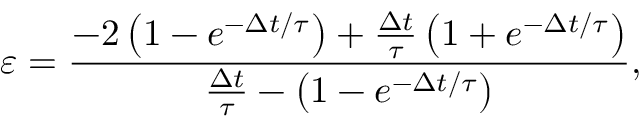Convert formula to latex. <formula><loc_0><loc_0><loc_500><loc_500>\varepsilon = \frac { - 2 \left ( { 1 - e ^ { - \Delta t / \tau } } \right ) + \frac { \Delta t } { \tau } \left ( { 1 + e ^ { - \Delta t / \tau } } \right ) } { \frac { \Delta t } { \tau } - \left ( { 1 - e ^ { - \Delta t / \tau } } \right ) } ,</formula> 